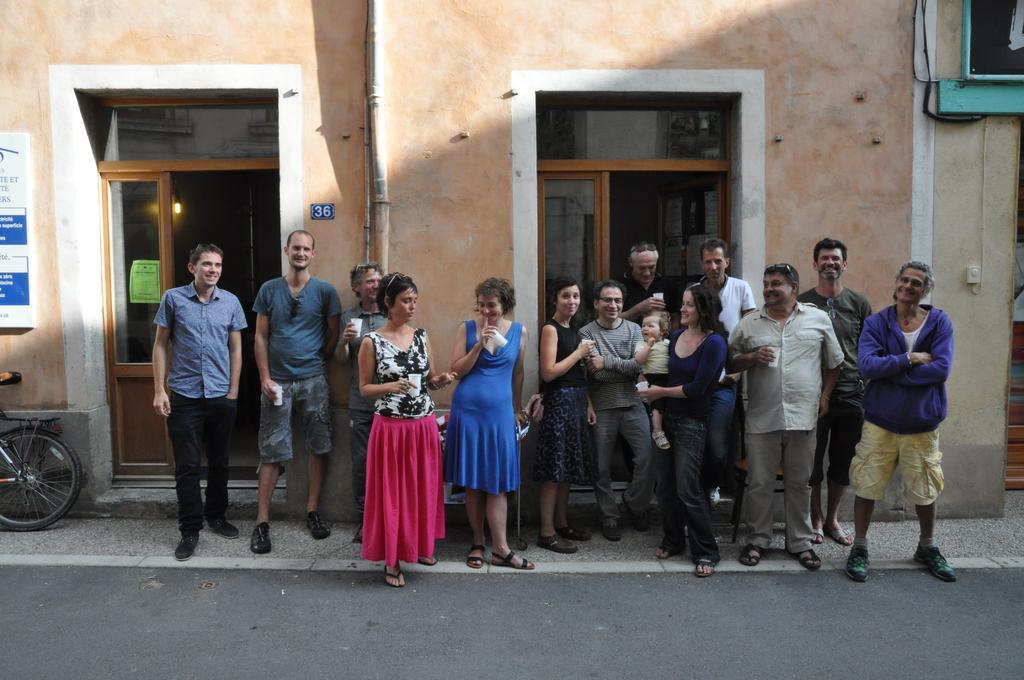Could you give a brief overview of what you see in this image? In this image, we can see a group of people. Few are holding some objects and smiling. At the bottom, there is a road. Here we can see a woman is holding a baby. Background there is a wall, pipes, some board, glass doors, poster. Right side top of the image, we can see some black color object here. Left side of the image, we can see a wheel. 